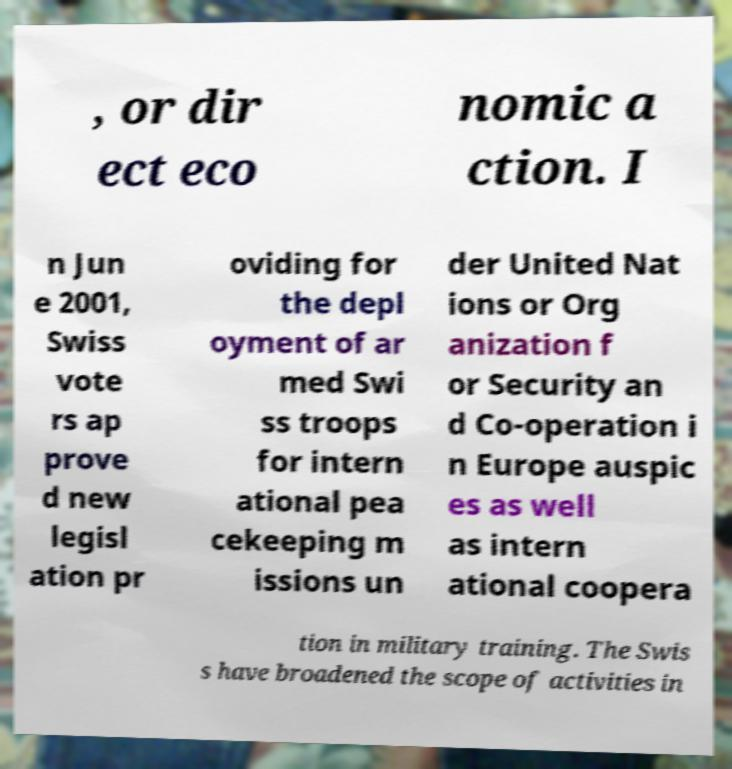Could you extract and type out the text from this image? , or dir ect eco nomic a ction. I n Jun e 2001, Swiss vote rs ap prove d new legisl ation pr oviding for the depl oyment of ar med Swi ss troops for intern ational pea cekeeping m issions un der United Nat ions or Org anization f or Security an d Co-operation i n Europe auspic es as well as intern ational coopera tion in military training. The Swis s have broadened the scope of activities in 